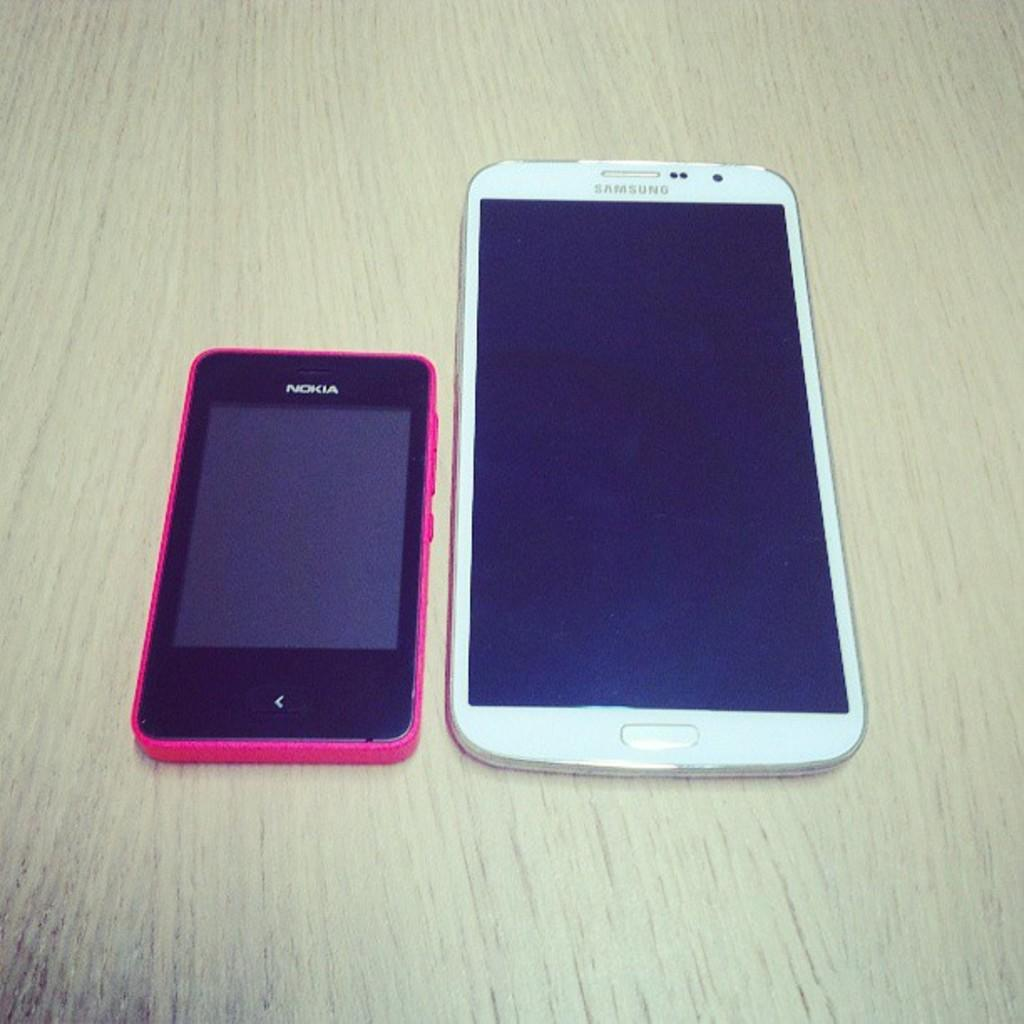<image>
Provide a brief description of the given image. A small pink Nokia phone sits next to a much larger Samsung phone. 